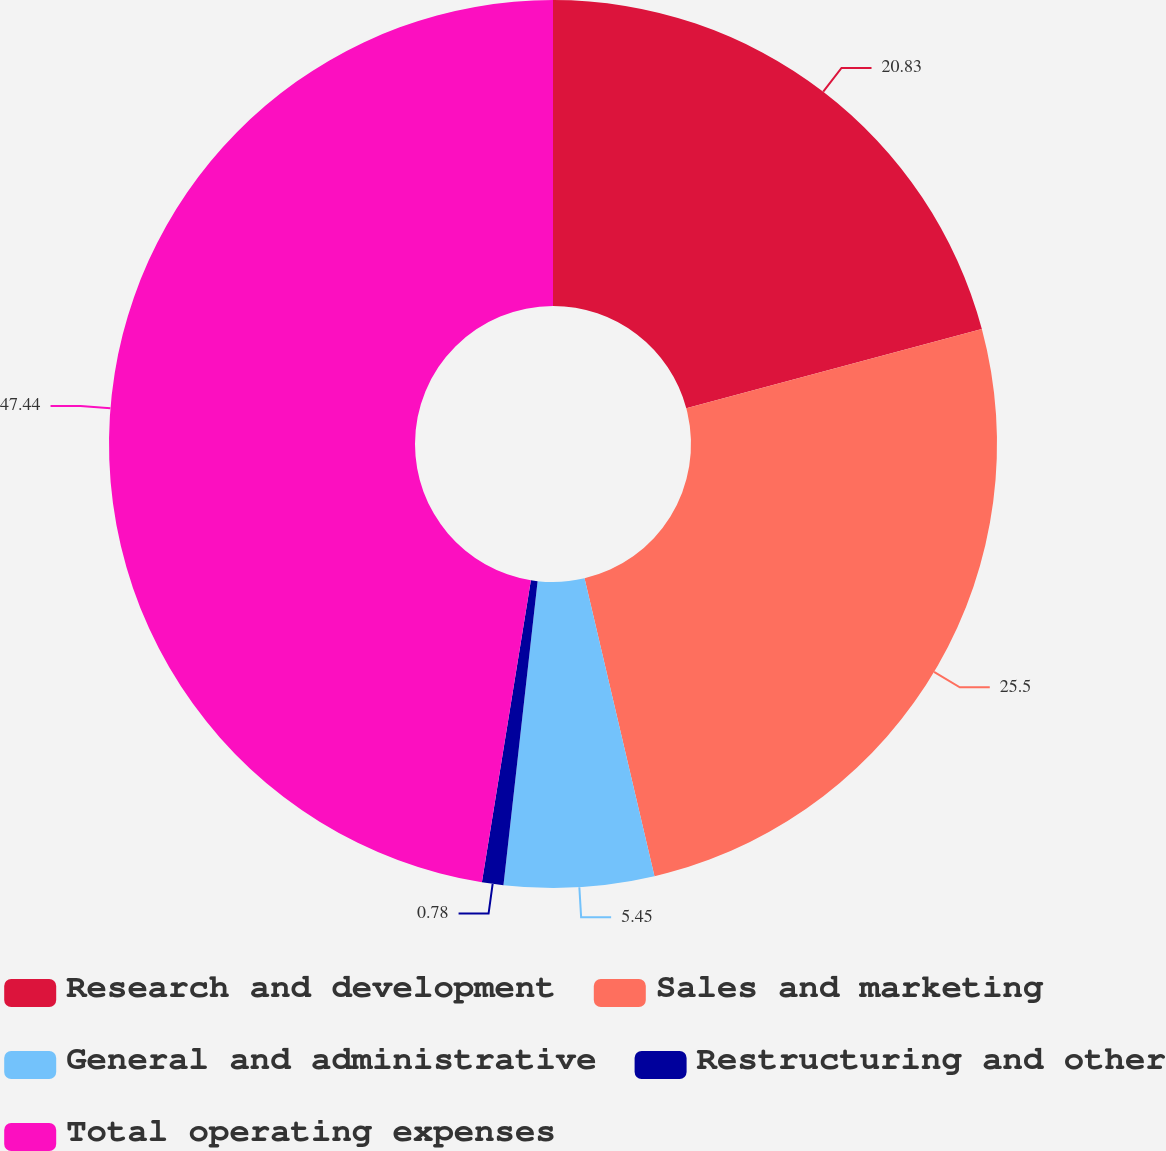<chart> <loc_0><loc_0><loc_500><loc_500><pie_chart><fcel>Research and development<fcel>Sales and marketing<fcel>General and administrative<fcel>Restructuring and other<fcel>Total operating expenses<nl><fcel>20.83%<fcel>25.5%<fcel>5.45%<fcel>0.78%<fcel>47.44%<nl></chart> 